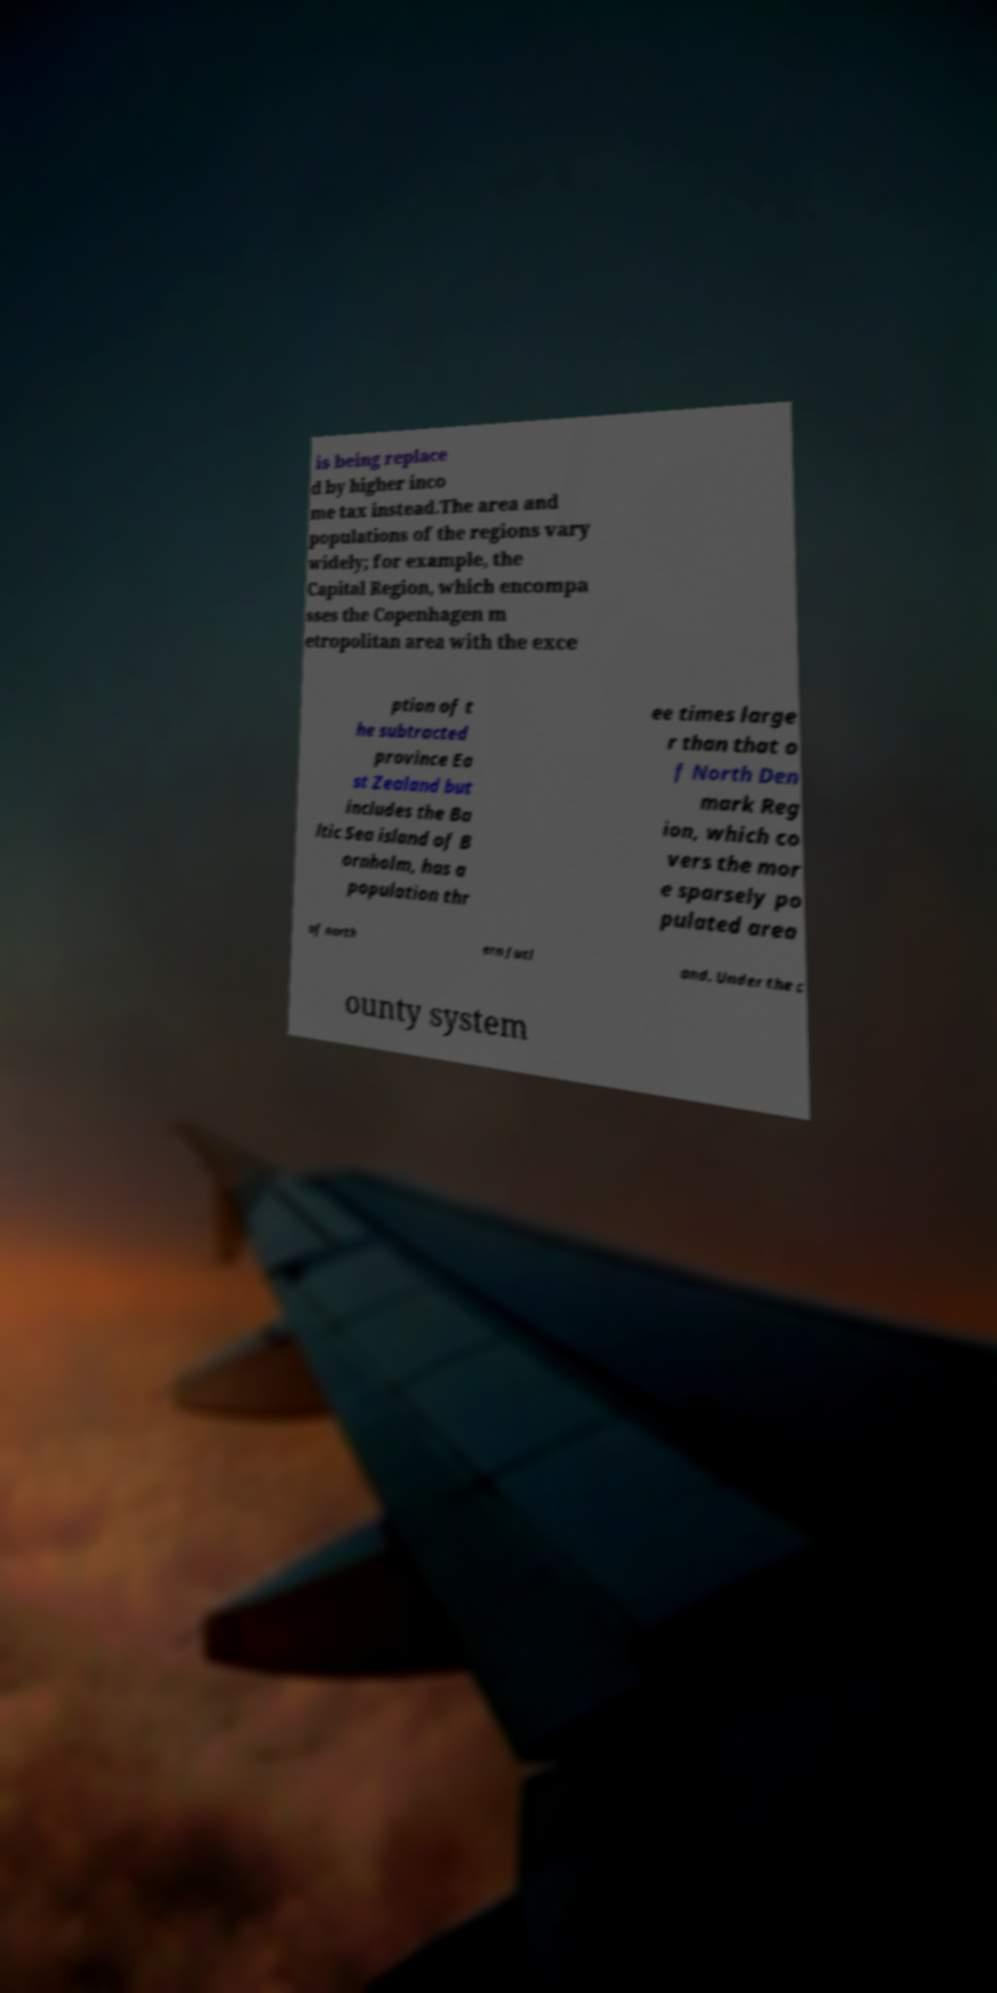There's text embedded in this image that I need extracted. Can you transcribe it verbatim? is being replace d by higher inco me tax instead.The area and populations of the regions vary widely; for example, the Capital Region, which encompa sses the Copenhagen m etropolitan area with the exce ption of t he subtracted province Ea st Zealand but includes the Ba ltic Sea island of B ornholm, has a population thr ee times large r than that o f North Den mark Reg ion, which co vers the mor e sparsely po pulated area of north ern Jutl and. Under the c ounty system 